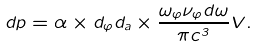<formula> <loc_0><loc_0><loc_500><loc_500>d p = \alpha \times d _ { \varphi } d _ { a } \times \frac { \omega _ { \varphi } \nu _ { \varphi } d \omega } { \pi c ^ { 3 } } V .</formula> 